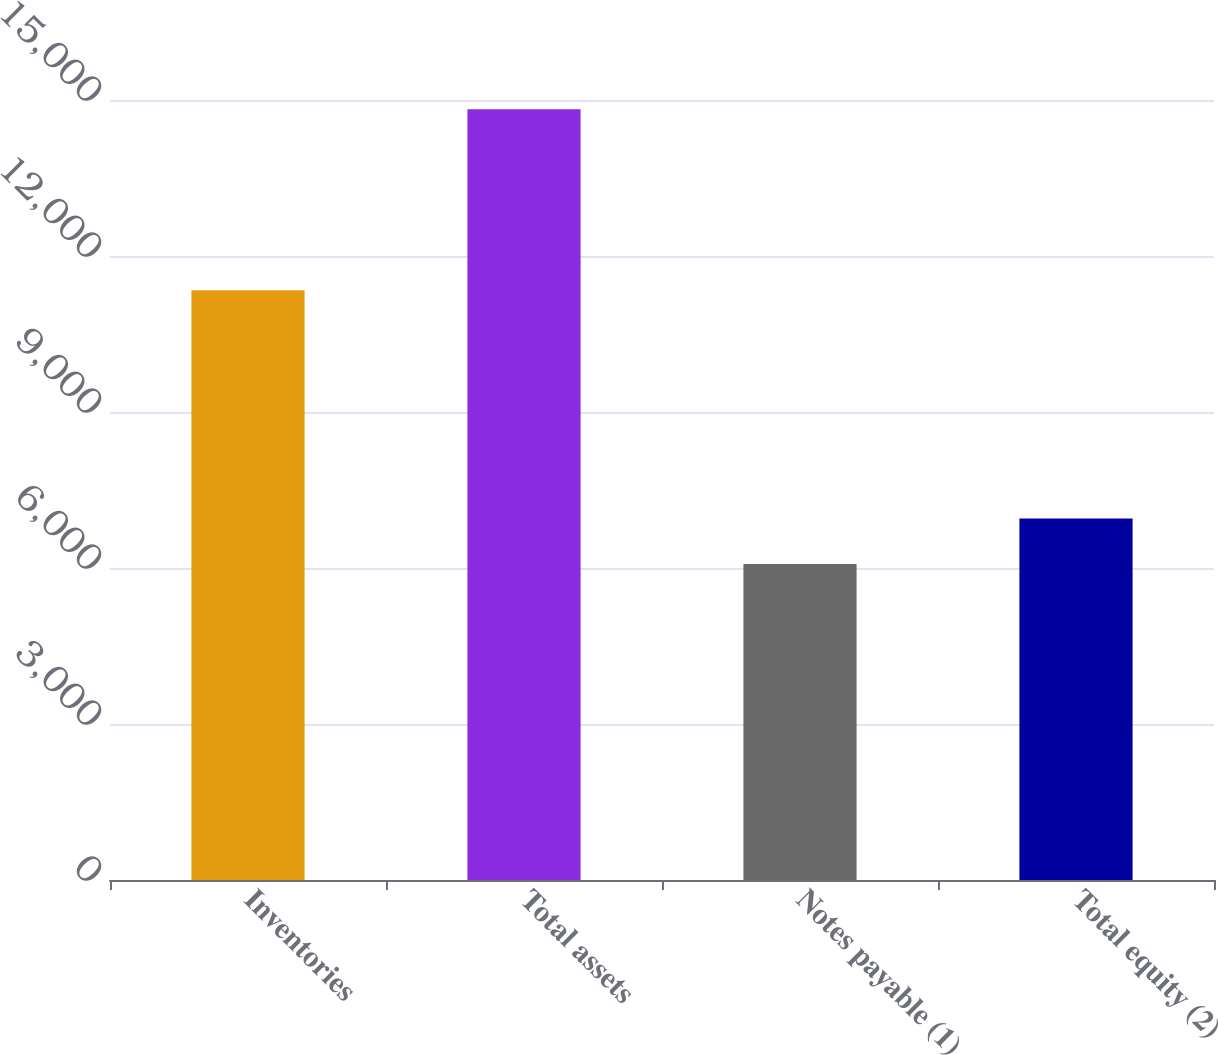Convert chart to OTSL. <chart><loc_0><loc_0><loc_500><loc_500><bar_chart><fcel>Inventories<fcel>Total assets<fcel>Notes payable (1)<fcel>Total equity (2)<nl><fcel>11343.1<fcel>14820.7<fcel>6078.6<fcel>6952.81<nl></chart> 